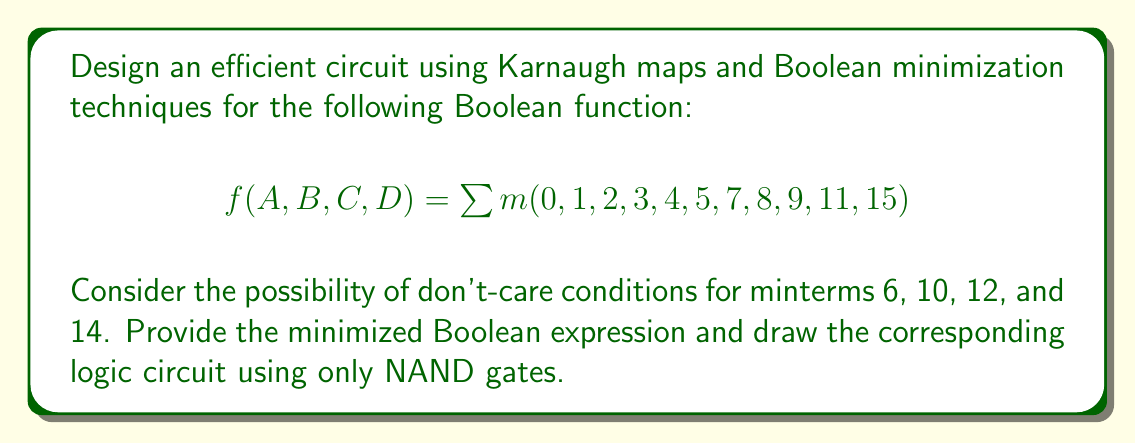Teach me how to tackle this problem. 1. First, let's create a 4-variable Karnaugh map with the given minterms and don't-care conditions:

[asy]
unitsize(1cm);

for(int i=0; i<4; ++i) {
  for(int j=0; j<4; ++j) {
    draw((i,j)--(i+1,j)--(i+1,j+1)--(i,j+1)--cycle);
  }
}

label("00", (0.5,-0.5));
label("01", (1.5,-0.5));
label("11", (2.5,-0.5));
label("10", (3.5,-0.5));

label("00", (-0.5,0.5));
label("01", (-0.5,1.5));
label("11", (-0.5,2.5));
label("10", (-0.5,3.5));

label("1", (0.5,0.5));
label("1", (1.5,0.5));
label("1", (2.5,0.5));
label("1", (3.5,0.5));
label("1", (0.5,1.5));
label("1", (1.5,1.5));
label("d", (2.5,1.5));
label("1", (3.5,1.5));
label("1", (0.5,2.5));
label("d", (1.5,2.5));
label("1", (2.5,2.5));
label("d", (3.5,2.5));
label("1", (0.5,3.5));
label("1", (1.5,3.5));
label("d", (2.5,3.5));
label("0", (3.5,3.5));

label("AB", (-1,4.5));
label("CD", (4.5,-1));
[/asy]

2. Identify the largest possible groups of 1's and don't-cares:
   - Group 1: 8 cells (ABCD, ABC'D, AB'CD, AB'C'D)
   - Group 2: 4 cells (A'B'CD, A'B'C'D)
   - Group 3: 2 cells (A'BC'D, A'BCD)

3. Write the Boolean expression for each group:
   - Group 1: $A$
   - Group 2: $A'B'C$
   - Group 3: $A'BD$

4. Combine the expressions using OR operations:
   $$f(A,B,C,D) = A + A'B'C + A'BD$$

5. To implement this using only NAND gates, we can use De Morgan's laws and the property that a NAND gate with a single input acts as an inverter:
   $$f(A,B,C,D) = \overline{\overline{A} \cdot \overline{A'B'C} \cdot \overline{A'BD}}$$

6. The logic circuit using only NAND gates would be:

[asy]
import geometry;

pair A = (0,0), B = (0,-1), C = (0,-2), D = (0,-3);
pair N1 = (2,-0.5), N2 = (2,-2), N3 = (4,-1.25), N4 = (6,0);

draw(A--N1);
draw(B--N1);
draw(C--N1);

draw(A--N2);
draw(B--N2);
draw(D--N2);

draw(N1--N3);
draw(N2--N3);

draw(A--(A.x+6,A.y));

draw((A.x+6,A.y)--N4);
draw(N3--N4);

label("A", A, W);
label("B", B, W);
label("C", C, W);
label("D", D, W);

filldraw(circle(N1,0.3), gray(0.9), black);
filldraw(circle(N2,0.3), gray(0.9), black);
filldraw(circle(N3,0.3), gray(0.9), black);
filldraw(circle(N4,0.3), gray(0.9), black);

label("f", (N4.x+0.5, N4.y), E);
[/asy]
Answer: $$f(A,B,C,D) = A + A'B'C + A'BD$$ 